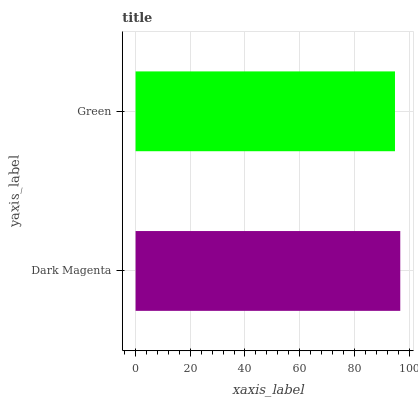Is Green the minimum?
Answer yes or no. Yes. Is Dark Magenta the maximum?
Answer yes or no. Yes. Is Green the maximum?
Answer yes or no. No. Is Dark Magenta greater than Green?
Answer yes or no. Yes. Is Green less than Dark Magenta?
Answer yes or no. Yes. Is Green greater than Dark Magenta?
Answer yes or no. No. Is Dark Magenta less than Green?
Answer yes or no. No. Is Dark Magenta the high median?
Answer yes or no. Yes. Is Green the low median?
Answer yes or no. Yes. Is Green the high median?
Answer yes or no. No. Is Dark Magenta the low median?
Answer yes or no. No. 